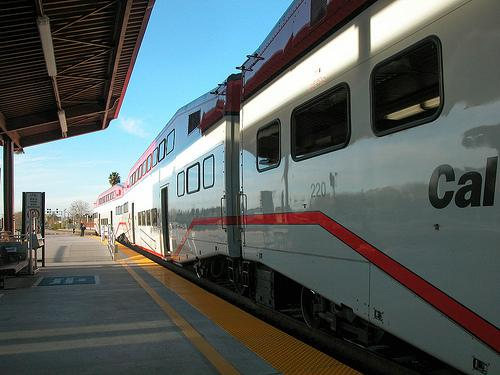Question: what is there?
Choices:
A. Plain.
B. Automobile.
C. Train.
D. Bike.
Answer with the letter. Answer: C Question: what is the sky like?
Choices:
A. Cloudy.
B. Dark.
C. Clear.
D. Blue.
Answer with the letter. Answer: D Question: where is this location?
Choices:
A. Train station.
B. A bus station.
C. An airport.
D. On a boat dock.
Answer with the letter. Answer: A 